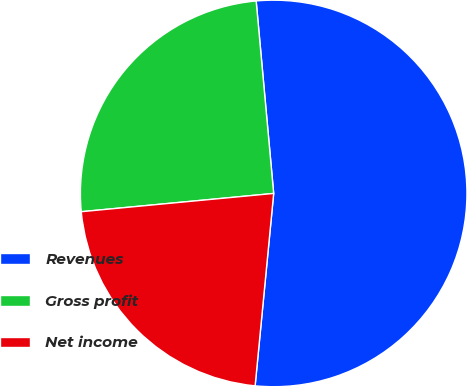<chart> <loc_0><loc_0><loc_500><loc_500><pie_chart><fcel>Revenues<fcel>Gross profit<fcel>Net income<nl><fcel>52.97%<fcel>25.06%<fcel>21.96%<nl></chart> 